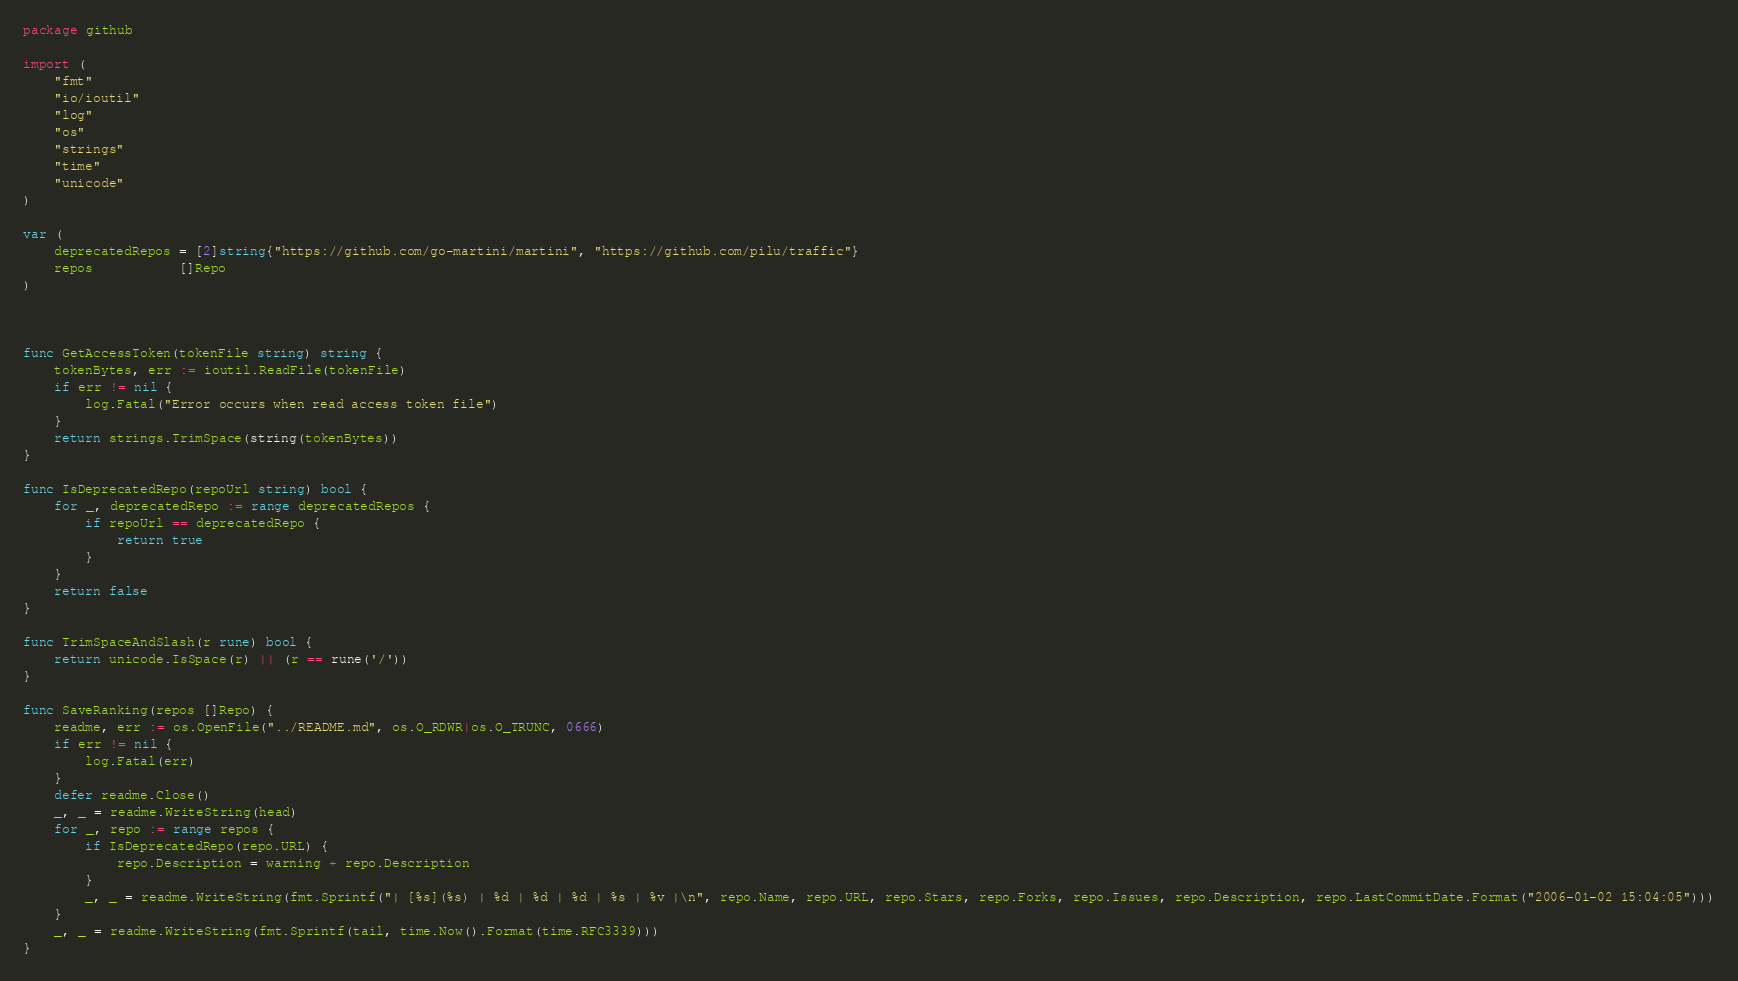Convert code to text. <code><loc_0><loc_0><loc_500><loc_500><_Go_>package github

import (
	"fmt"
	"io/ioutil"
	"log"
	"os"
	"strings"
	"time"
	"unicode"
)

var (
	deprecatedRepos = [2]string{"https://github.com/go-martini/martini", "https://github.com/pilu/traffic"}
	repos           []Repo
)



func GetAccessToken(tokenFile string) string {
	tokenBytes, err := ioutil.ReadFile(tokenFile)
	if err != nil {
		log.Fatal("Error occurs when read access token file")
	}
	return strings.TrimSpace(string(tokenBytes))
}

func IsDeprecatedRepo(repoUrl string) bool {
	for _, deprecatedRepo := range deprecatedRepos {
		if repoUrl == deprecatedRepo {
			return true
		}
	}
	return false
}

func TrimSpaceAndSlash(r rune) bool {
	return unicode.IsSpace(r) || (r == rune('/'))
}

func SaveRanking(repos []Repo) {
	readme, err := os.OpenFile("../README.md", os.O_RDWR|os.O_TRUNC, 0666)
	if err != nil {
		log.Fatal(err)
	}
	defer readme.Close()
	_, _ = readme.WriteString(head)
	for _, repo := range repos {
		if IsDeprecatedRepo(repo.URL) {
			repo.Description = warning + repo.Description
		}
		_, _ = readme.WriteString(fmt.Sprintf("| [%s](%s) | %d | %d | %d | %s | %v |\n", repo.Name, repo.URL, repo.Stars, repo.Forks, repo.Issues, repo.Description, repo.LastCommitDate.Format("2006-01-02 15:04:05")))
	}
	_, _ = readme.WriteString(fmt.Sprintf(tail, time.Now().Format(time.RFC3339)))
}
</code> 